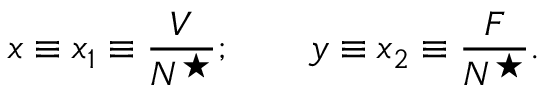<formula> <loc_0><loc_0><loc_500><loc_500>x \equiv x _ { 1 } \equiv \frac { V } { N ^ { ^ { * } } } ; \quad y \equiv x _ { 2 } \equiv \frac { F } { N ^ { ^ { * } } } .</formula> 